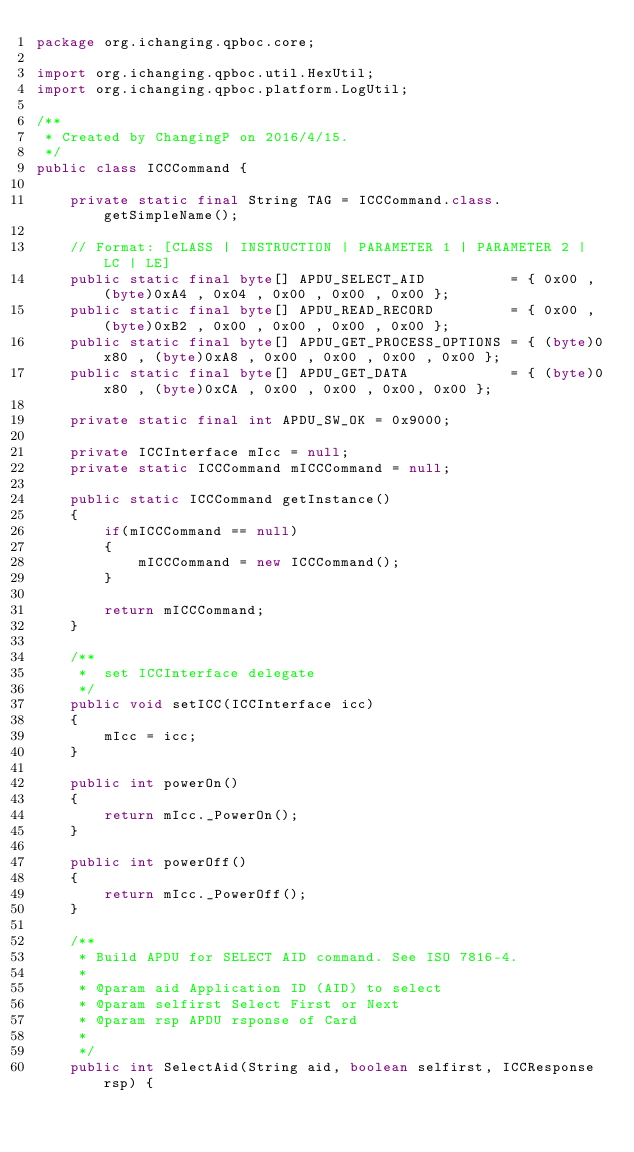<code> <loc_0><loc_0><loc_500><loc_500><_Java_>package org.ichanging.qpboc.core;

import org.ichanging.qpboc.util.HexUtil;
import org.ichanging.qpboc.platform.LogUtil;

/**
 * Created by ChangingP on 2016/4/15.
 */
public class ICCCommand {

    private static final String TAG = ICCCommand.class.getSimpleName();

    // Format: [CLASS | INSTRUCTION | PARAMETER 1 | PARAMETER 2 | LC | LE]
    public static final byte[] APDU_SELECT_AID          = { 0x00 , (byte)0xA4 , 0x04 , 0x00 , 0x00 , 0x00 };
    public static final byte[] APDU_READ_RECORD         = { 0x00 , (byte)0xB2 , 0x00 , 0x00 , 0x00 , 0x00 };
    public static final byte[] APDU_GET_PROCESS_OPTIONS = { (byte)0x80 , (byte)0xA8 , 0x00 , 0x00 , 0x00 , 0x00 };
    public static final byte[] APDU_GET_DATA            = { (byte)0x80 , (byte)0xCA , 0x00 , 0x00 , 0x00, 0x00 };

    private static final int APDU_SW_OK = 0x9000;

    private ICCInterface mIcc = null;
    private static ICCCommand mICCCommand = null;

    public static ICCCommand getInstance()
    {
        if(mICCCommand == null)
        {
            mICCCommand = new ICCCommand();
        }

        return mICCCommand;
    }

    /**
     *  set ICCInterface delegate
     */
    public void setICC(ICCInterface icc)
    {
        mIcc = icc;
    }

    public int powerOn()
    {
        return mIcc._PowerOn();
    }

    public int powerOff()
    {
        return mIcc._PowerOff();
    }

    /**
     * Build APDU for SELECT AID command. See ISO 7816-4.
     *
     * @param aid Application ID (AID) to select
     * @param selfirst Select First or Next
     * @param rsp APDU rsponse of Card
     *
     */
    public int SelectAid(String aid, boolean selfirst, ICCResponse rsp) {
</code> 